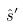Convert formula to latex. <formula><loc_0><loc_0><loc_500><loc_500>\hat { s } ^ { \prime }</formula> 